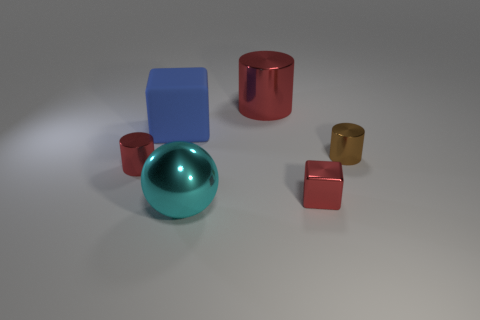Subtract all tiny brown metal cylinders. How many cylinders are left? 2 Add 4 tiny brown metal things. How many objects exist? 10 Subtract all brown cylinders. How many cylinders are left? 2 Subtract 0 yellow balls. How many objects are left? 6 Subtract all blocks. How many objects are left? 4 Subtract all cyan cylinders. Subtract all yellow spheres. How many cylinders are left? 3 Subtract all blue balls. How many red cylinders are left? 2 Subtract all brown metal blocks. Subtract all tiny red things. How many objects are left? 4 Add 4 big matte blocks. How many big matte blocks are left? 5 Add 5 rubber blocks. How many rubber blocks exist? 6 